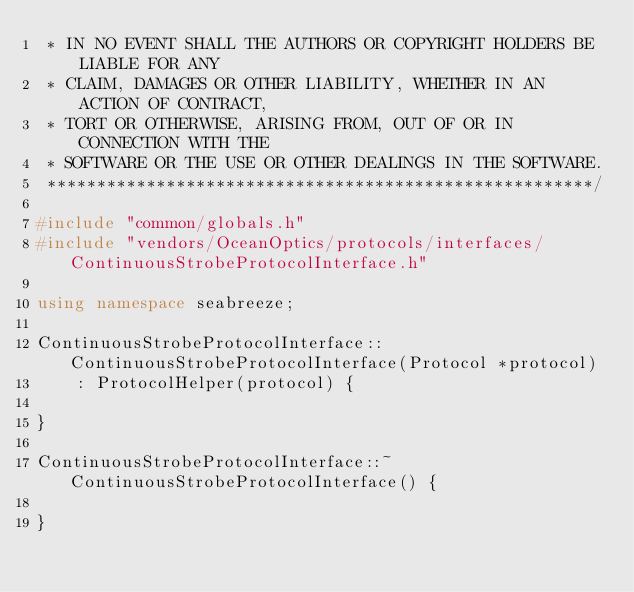Convert code to text. <code><loc_0><loc_0><loc_500><loc_500><_C++_> * IN NO EVENT SHALL THE AUTHORS OR COPYRIGHT HOLDERS BE LIABLE FOR ANY
 * CLAIM, DAMAGES OR OTHER LIABILITY, WHETHER IN AN ACTION OF CONTRACT,
 * TORT OR OTHERWISE, ARISING FROM, OUT OF OR IN CONNECTION WITH THE
 * SOFTWARE OR THE USE OR OTHER DEALINGS IN THE SOFTWARE.
 *******************************************************/

#include "common/globals.h"
#include "vendors/OceanOptics/protocols/interfaces/ContinuousStrobeProtocolInterface.h"

using namespace seabreeze;

ContinuousStrobeProtocolInterface::ContinuousStrobeProtocolInterface(Protocol *protocol)
    : ProtocolHelper(protocol) {

}

ContinuousStrobeProtocolInterface::~ContinuousStrobeProtocolInterface() {

}
</code> 